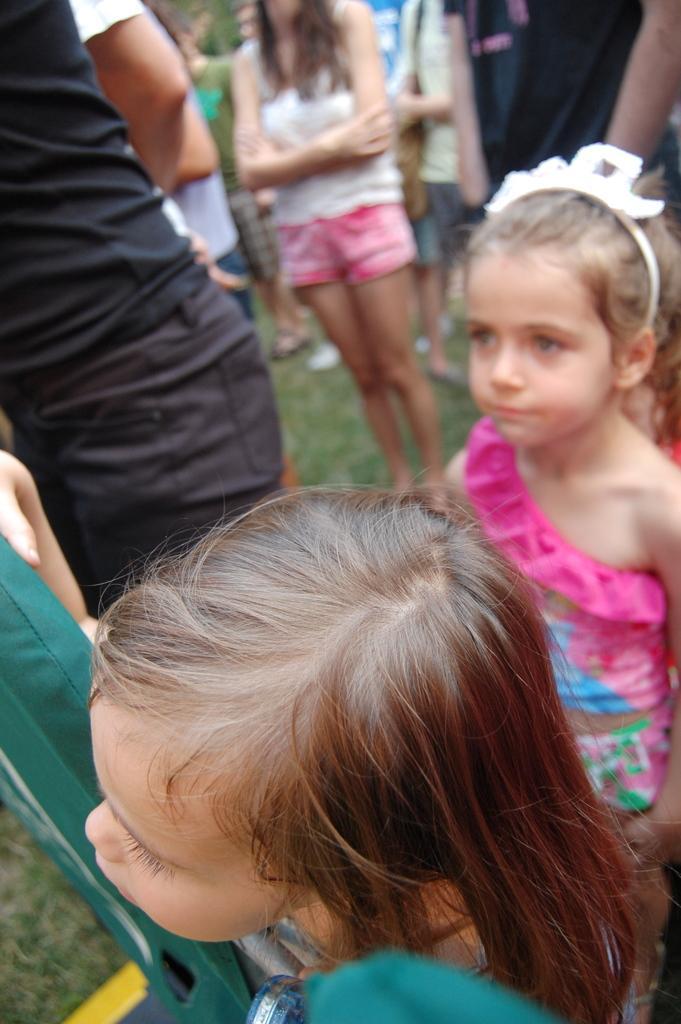In one or two sentences, can you explain what this image depicts? In this picture I can see few people standing and I can see couple of girls and I can see grass on the ground. 